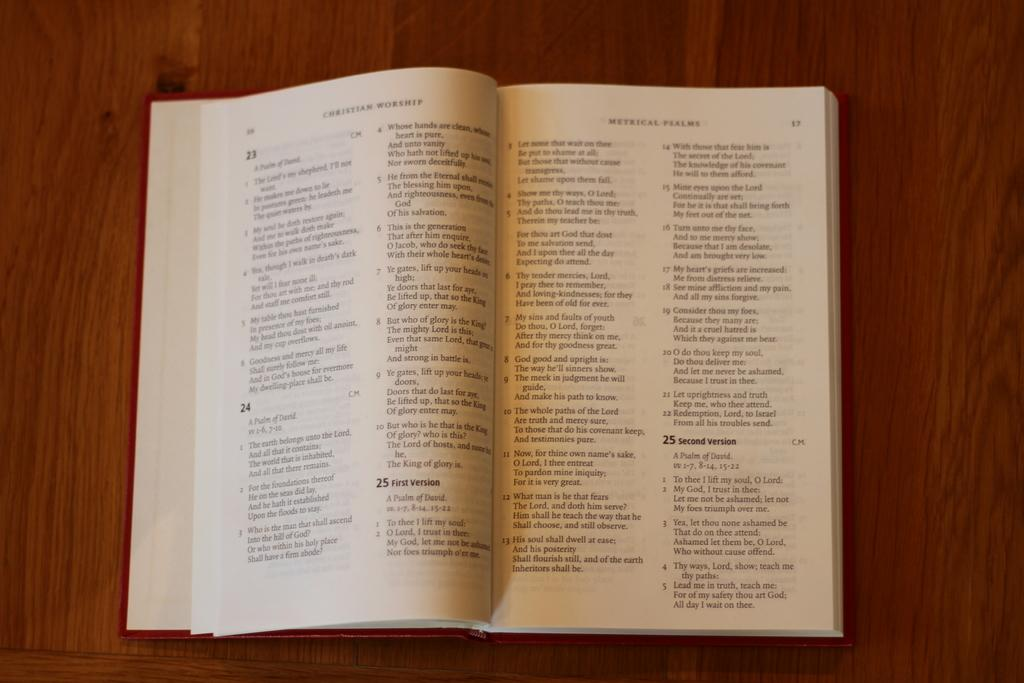<image>
Summarize the visual content of the image. A book open to page 23 and 24. 